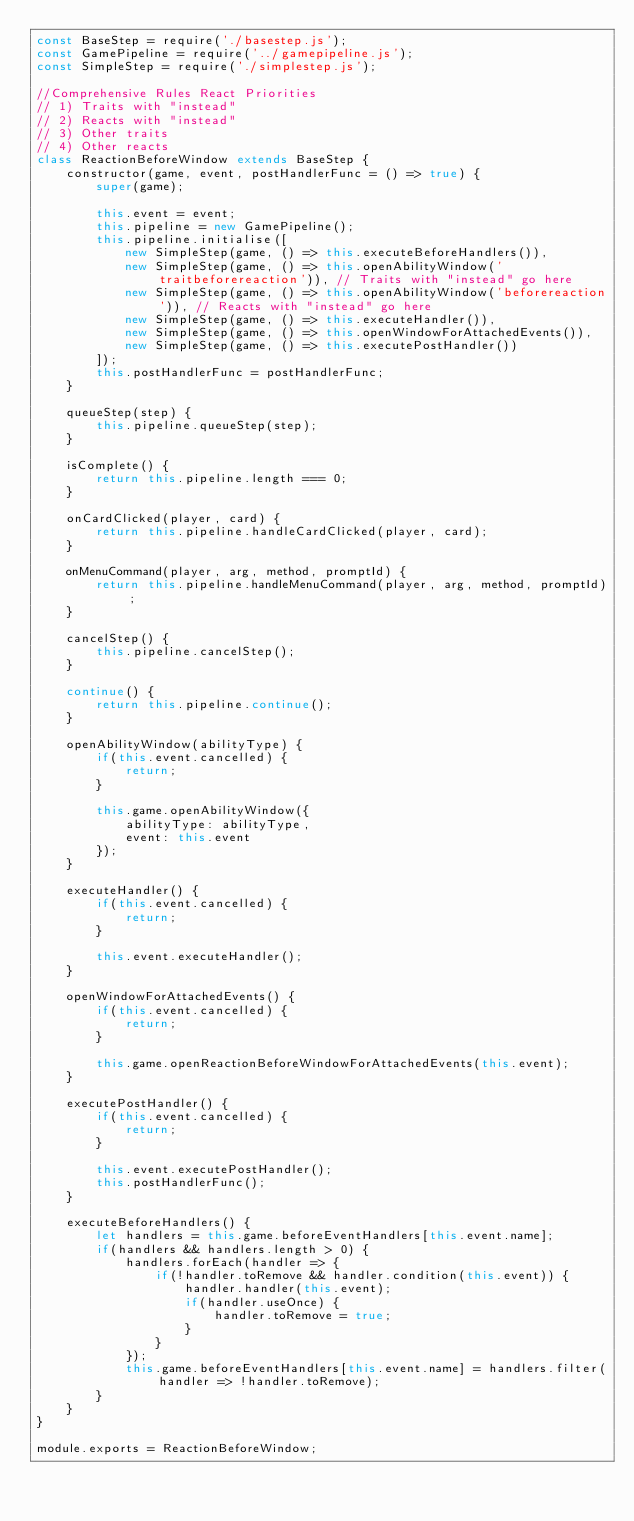<code> <loc_0><loc_0><loc_500><loc_500><_JavaScript_>const BaseStep = require('./basestep.js');
const GamePipeline = require('../gamepipeline.js');
const SimpleStep = require('./simplestep.js');

//Comprehensive Rules React Priorities
// 1) Traits with "instead"
// 2) Reacts with "instead"
// 3) Other traits
// 4) Other reacts
class ReactionBeforeWindow extends BaseStep {
    constructor(game, event, postHandlerFunc = () => true) {
        super(game);

        this.event = event;
        this.pipeline = new GamePipeline();
        this.pipeline.initialise([
            new SimpleStep(game, () => this.executeBeforeHandlers()),
            new SimpleStep(game, () => this.openAbilityWindow('traitbeforereaction')), // Traits with "instead" go here
            new SimpleStep(game, () => this.openAbilityWindow('beforereaction')), // Reacts with "instead" go here
            new SimpleStep(game, () => this.executeHandler()),
            new SimpleStep(game, () => this.openWindowForAttachedEvents()),
            new SimpleStep(game, () => this.executePostHandler())
        ]);
        this.postHandlerFunc = postHandlerFunc;
    }

    queueStep(step) {
        this.pipeline.queueStep(step);
    }

    isComplete() {
        return this.pipeline.length === 0;
    }

    onCardClicked(player, card) {
        return this.pipeline.handleCardClicked(player, card);
    }

    onMenuCommand(player, arg, method, promptId) {
        return this.pipeline.handleMenuCommand(player, arg, method, promptId);
    }

    cancelStep() {
        this.pipeline.cancelStep();
    }

    continue() {
        return this.pipeline.continue();
    }

    openAbilityWindow(abilityType) {
        if(this.event.cancelled) {
            return;
        }

        this.game.openAbilityWindow({
            abilityType: abilityType,
            event: this.event
        });
    }

    executeHandler() {
        if(this.event.cancelled) {
            return;
        }

        this.event.executeHandler();
    }

    openWindowForAttachedEvents() {
        if(this.event.cancelled) {
            return;
        }

        this.game.openReactionBeforeWindowForAttachedEvents(this.event);
    }

    executePostHandler() {
        if(this.event.cancelled) {
            return;
        }

        this.event.executePostHandler();
        this.postHandlerFunc();
    }

    executeBeforeHandlers() {
        let handlers = this.game.beforeEventHandlers[this.event.name];
        if(handlers && handlers.length > 0) {
            handlers.forEach(handler => {
                if(!handler.toRemove && handler.condition(this.event)) {
                    handler.handler(this.event);
                    if(handler.useOnce) {
                        handler.toRemove = true;
                    }
                }
            });
            this.game.beforeEventHandlers[this.event.name] = handlers.filter(handler => !handler.toRemove);
        }
    }
}

module.exports = ReactionBeforeWindow;
</code> 